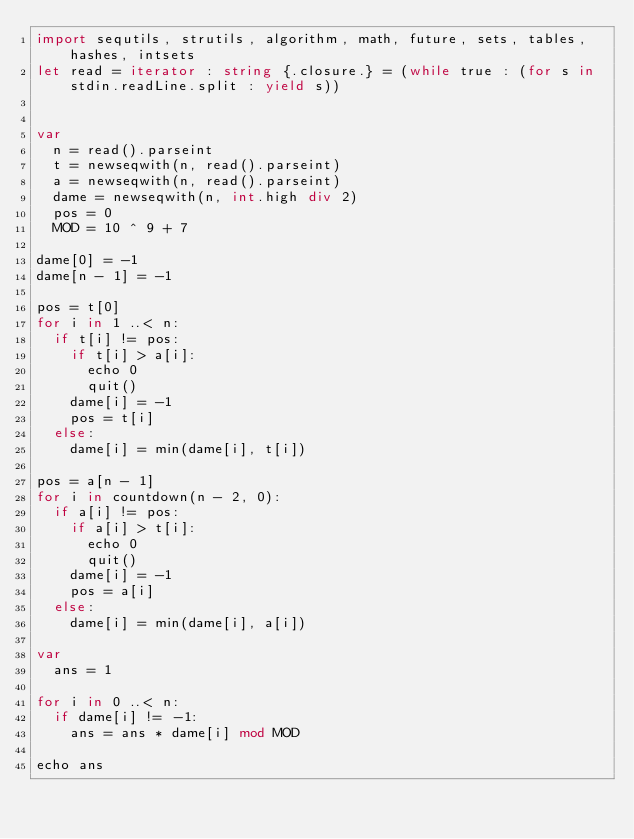<code> <loc_0><loc_0><loc_500><loc_500><_Nim_>import sequtils, strutils, algorithm, math, future, sets, tables, hashes, intsets
let read = iterator : string {.closure.} = (while true : (for s in stdin.readLine.split : yield s))


var
  n = read().parseint
  t = newseqwith(n, read().parseint)
  a = newseqwith(n, read().parseint)
  dame = newseqwith(n, int.high div 2)
  pos = 0
  MOD = 10 ^ 9 + 7

dame[0] = -1
dame[n - 1] = -1

pos = t[0]
for i in 1 ..< n:
  if t[i] != pos:
    if t[i] > a[i]:
      echo 0
      quit()
    dame[i] = -1
    pos = t[i]
  else:
    dame[i] = min(dame[i], t[i])

pos = a[n - 1]
for i in countdown(n - 2, 0):
  if a[i] != pos:
    if a[i] > t[i]:
      echo 0
      quit()
    dame[i] = -1
    pos = a[i]
  else:
    dame[i] = min(dame[i], a[i])

var
  ans = 1

for i in 0 ..< n:
  if dame[i] != -1:
    ans = ans * dame[i] mod MOD

echo ans






</code> 